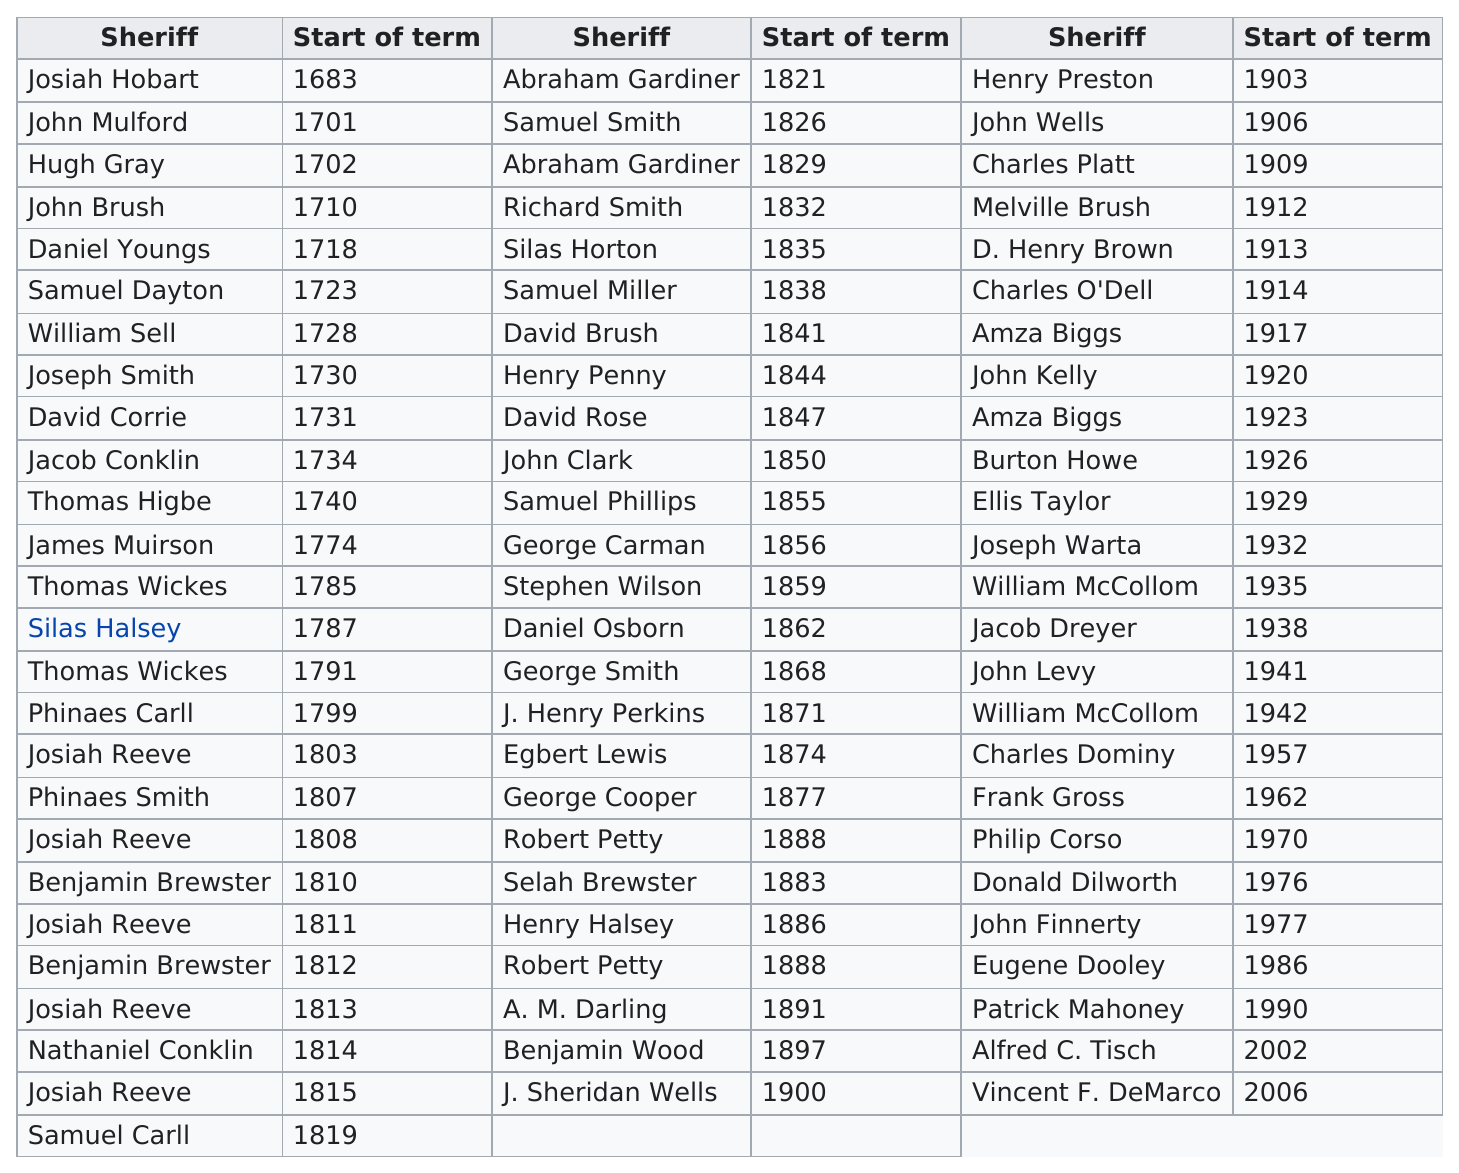Point out several critical features in this image. Suffolk County has had fewer than 200 sheriffs at some point in time. Robert Petty did not serve before Josiah Reeve. In the United States, there is at least one individual with the last name 'Biggs' who holds the position of sheriff. In Suffolk County between 1903 and 1957, there were a total of 17 sheriffs who held office during that time period. Before Amza Biggs served as the sheriff of Suffolk County, Charles O'Dell was the sheriff of Suffolk County. 